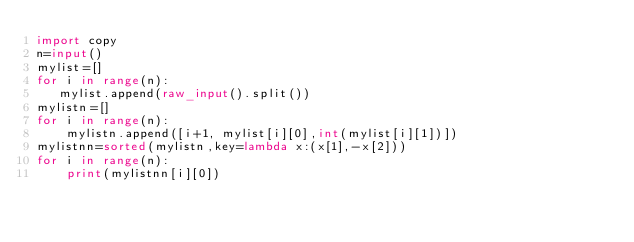Convert code to text. <code><loc_0><loc_0><loc_500><loc_500><_Python_>import copy
n=input()
mylist=[]
for i in range(n):
   mylist.append(raw_input().split())
mylistn=[]
for i in range(n):
    mylistn.append([i+1, mylist[i][0],int(mylist[i][1])])
mylistnn=sorted(mylistn,key=lambda x:(x[1],-x[2]))
for i in range(n):
    print(mylistnn[i][0])</code> 